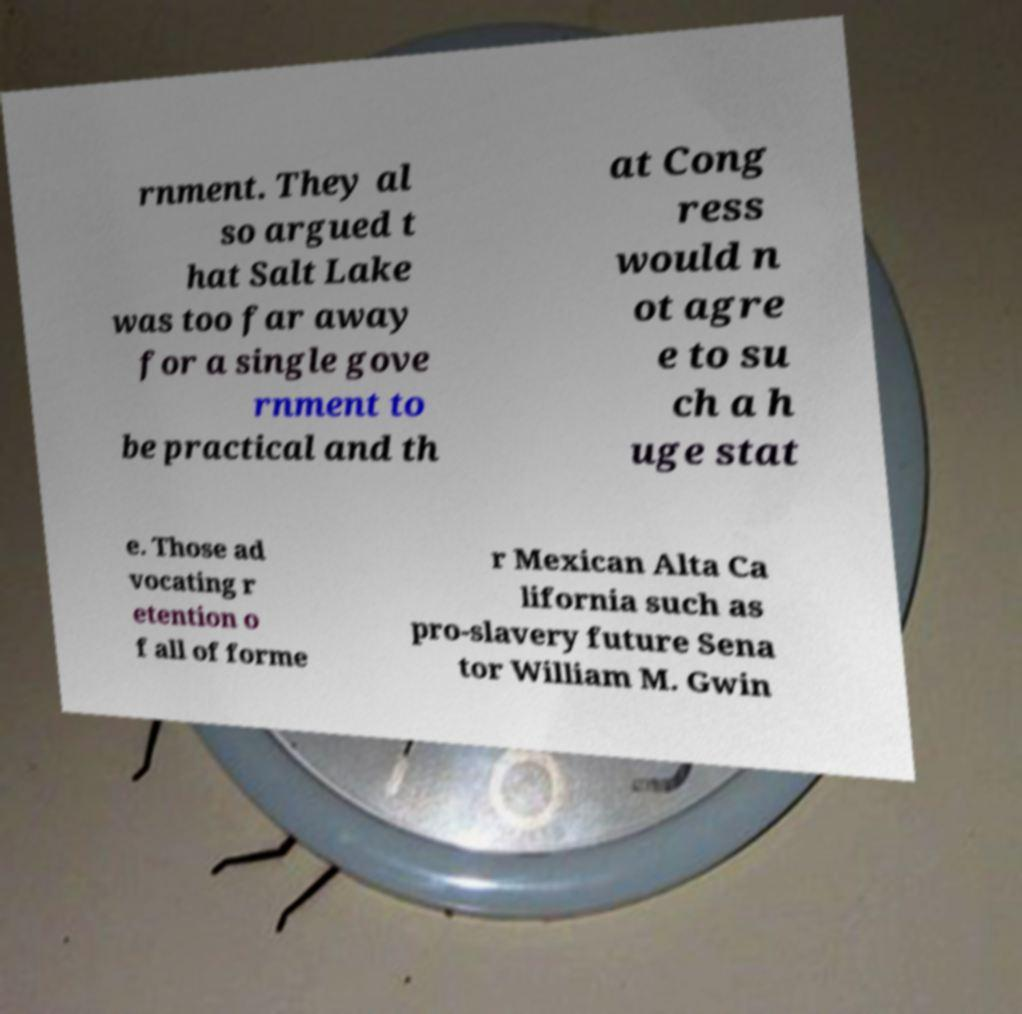For documentation purposes, I need the text within this image transcribed. Could you provide that? rnment. They al so argued t hat Salt Lake was too far away for a single gove rnment to be practical and th at Cong ress would n ot agre e to su ch a h uge stat e. Those ad vocating r etention o f all of forme r Mexican Alta Ca lifornia such as pro-slavery future Sena tor William M. Gwin 